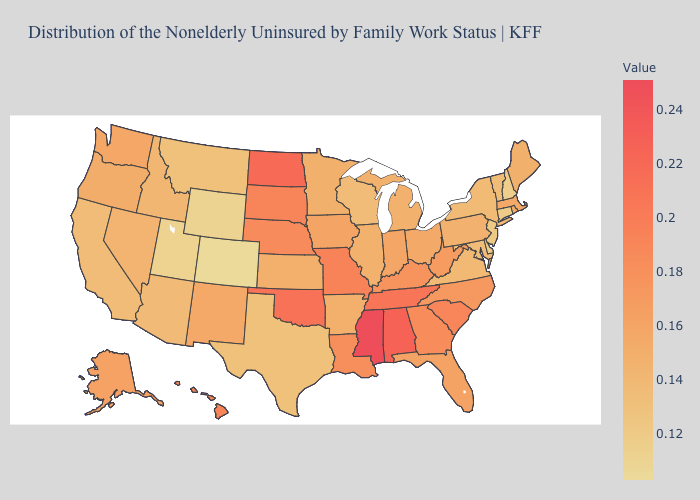Which states have the highest value in the USA?
Quick response, please. Mississippi. Does the map have missing data?
Short answer required. No. Does Utah have the lowest value in the West?
Keep it brief. No. Among the states that border California , which have the lowest value?
Keep it brief. Arizona. Among the states that border Michigan , does Indiana have the lowest value?
Concise answer only. No. Among the states that border Vermont , does New Hampshire have the lowest value?
Be succinct. Yes. 